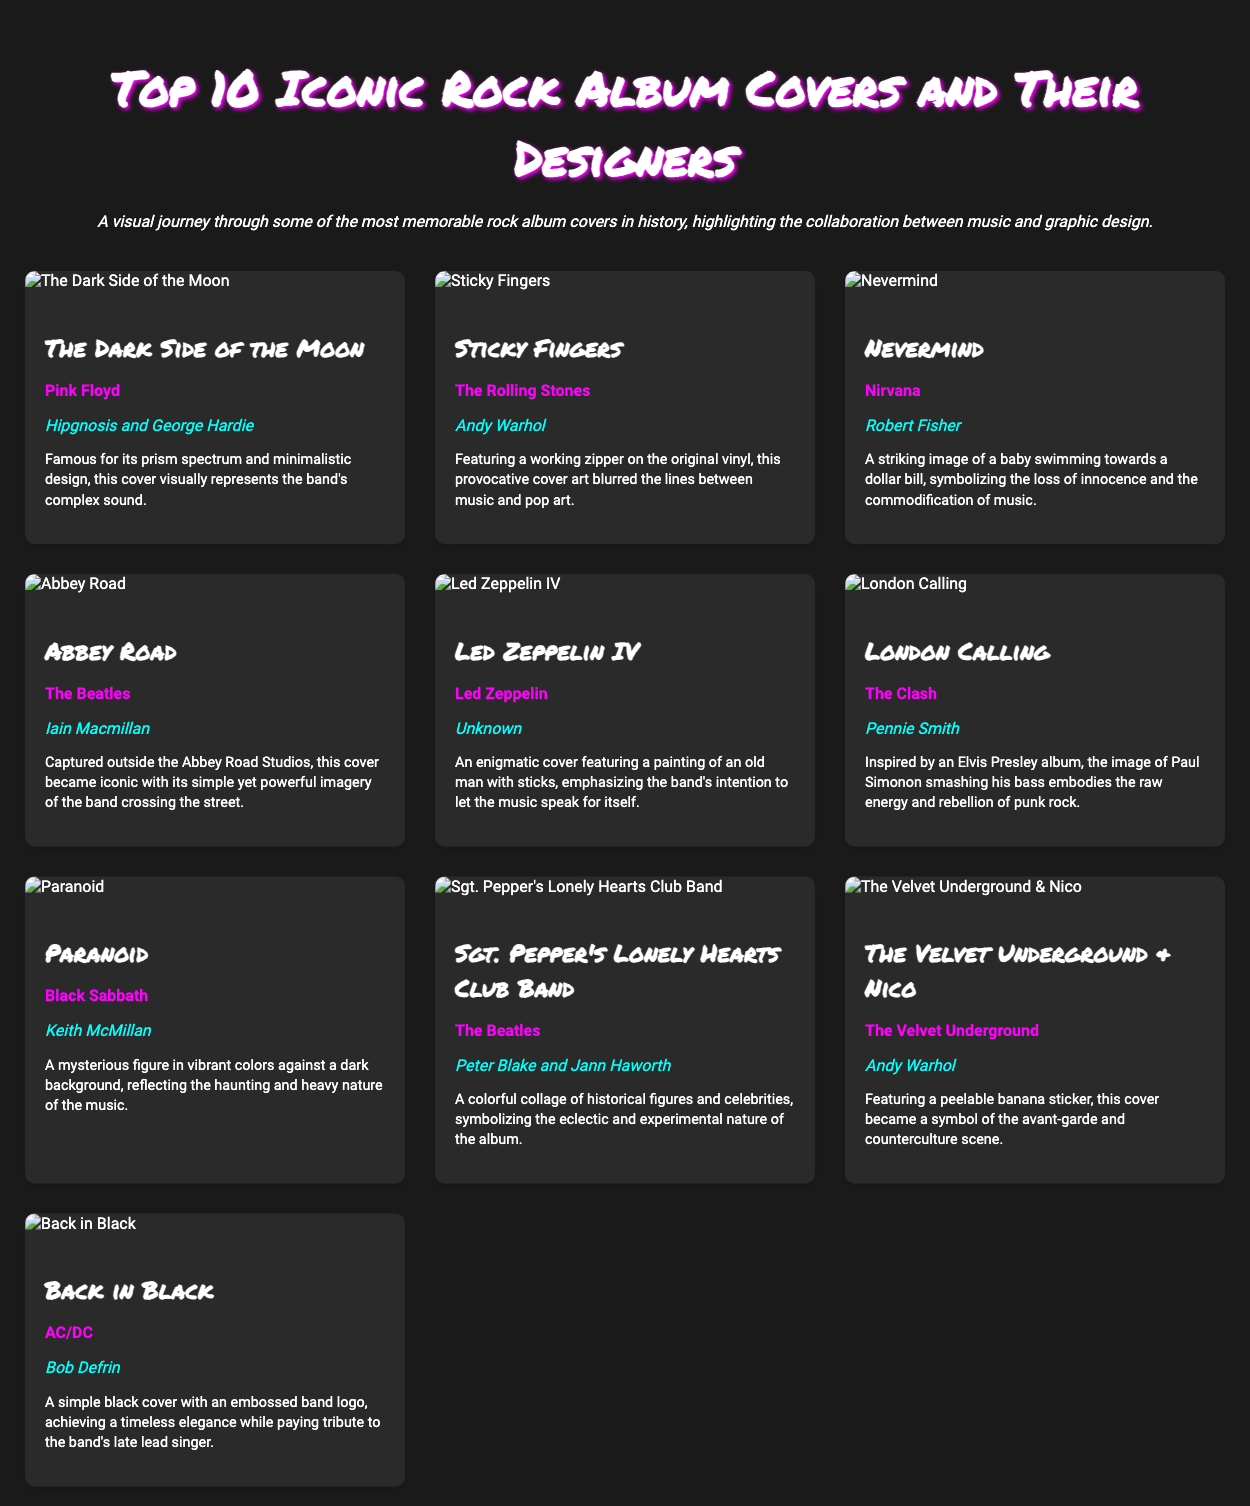What is the title of the album cover designed by Hipgnosis and George Hardie? The document lists "The Dark Side of the Moon" as the album cover designed by Hipgnosis and George Hardie.
Answer: The Dark Side of the Moon Who is the artist of the album "Sticky Fingers"? The album "Sticky Fingers" is attributed to The Rolling Stones as mentioned in the document.
Answer: The Rolling Stones Which album cover features a baby swimming towards a dollar bill? The description for "Nevermind" specifies this striking image.
Answer: Nevermind What unique physical element is featured on the "Sticky Fingers" album cover? The document notes that the original vinyl had a working zipper, highlighting its provocative design.
Answer: Working zipper Which two designers created the cover for "Sgt. Pepper's Lonely Hearts Club Band"? The document cites Peter Blake and Jann Haworth as the designers.
Answer: Peter Blake and Jann Haworth What color is the background of the "Back in Black" album cover? The document states that the "Back in Black" cover is simple and black, emphasizing its elegant tribute.
Answer: Black How many album covers in the list are designed by Andy Warhol? The document lists "Sticky Fingers" and "The Velvet Underground & Nico" as covers designed by Andy Warhol, totaling two.
Answer: Two Which artist's graphic design incorporates a collage of historical figures? The album "Sgt. Pepper's Lonely Hearts Club Band" is noted for its colorful collage in the document.
Answer: The Beatles What is the overall theme of the document? The document highlights the relationship between music and graphic design through iconic rock album covers.
Answer: Iconic rock album covers 